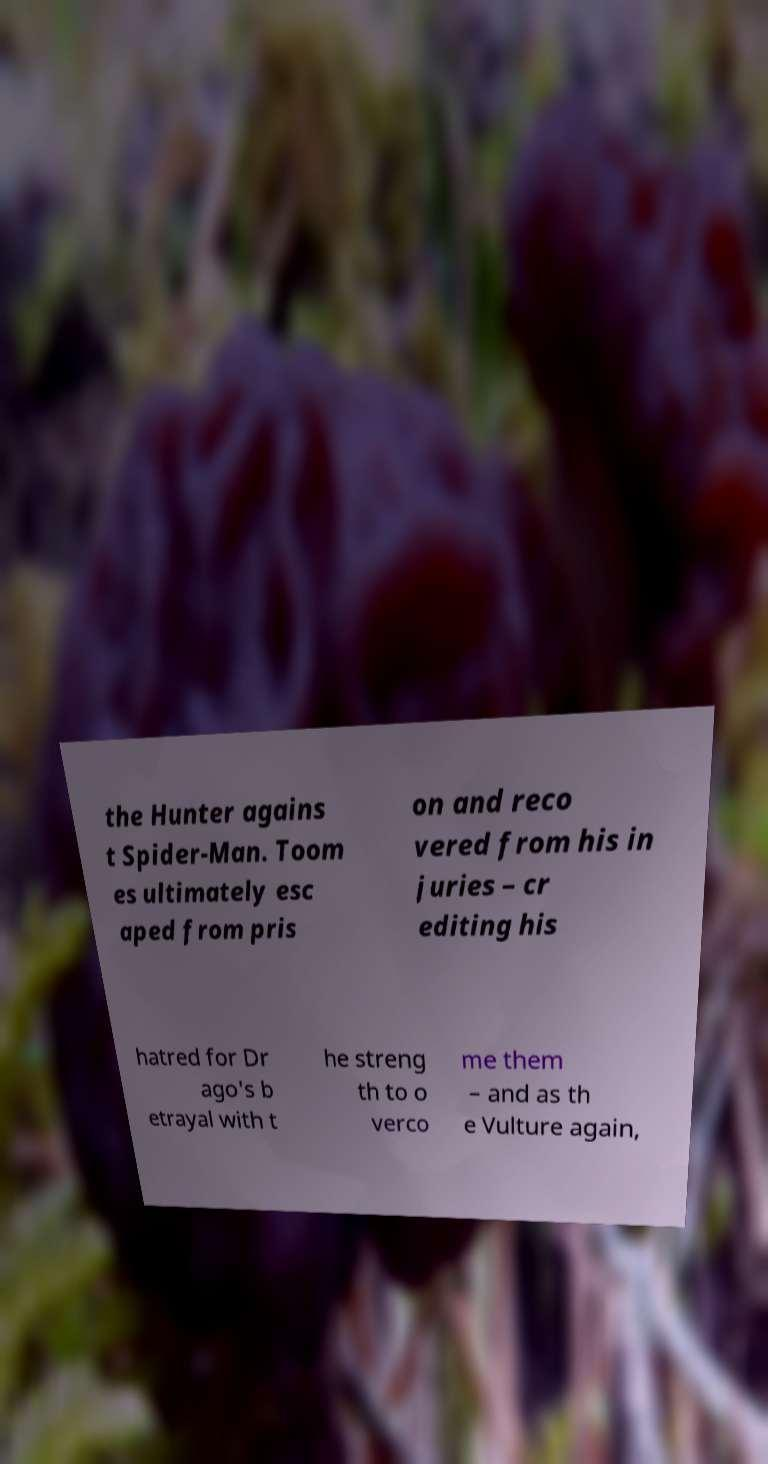For documentation purposes, I need the text within this image transcribed. Could you provide that? the Hunter agains t Spider-Man. Toom es ultimately esc aped from pris on and reco vered from his in juries – cr editing his hatred for Dr ago's b etrayal with t he streng th to o verco me them – and as th e Vulture again, 